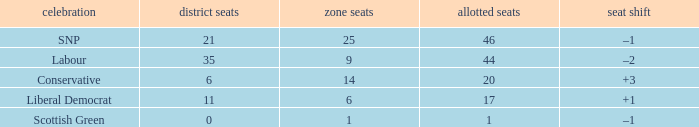How many regional seats were there with the SNP party and where the number of total seats was bigger than 46? 0.0. 